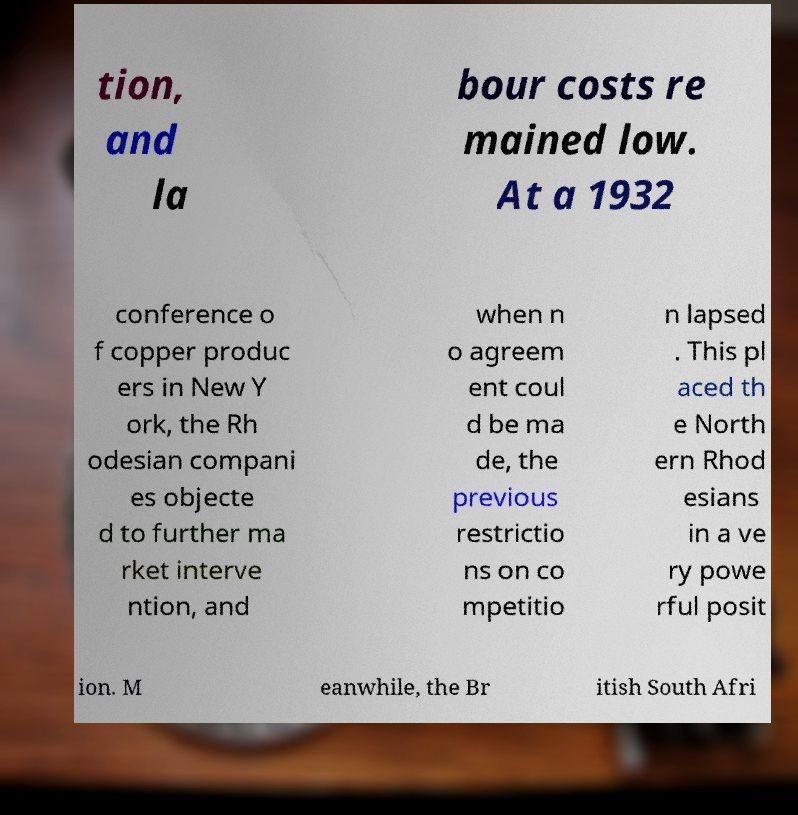Please identify and transcribe the text found in this image. tion, and la bour costs re mained low. At a 1932 conference o f copper produc ers in New Y ork, the Rh odesian compani es objecte d to further ma rket interve ntion, and when n o agreem ent coul d be ma de, the previous restrictio ns on co mpetitio n lapsed . This pl aced th e North ern Rhod esians in a ve ry powe rful posit ion. M eanwhile, the Br itish South Afri 